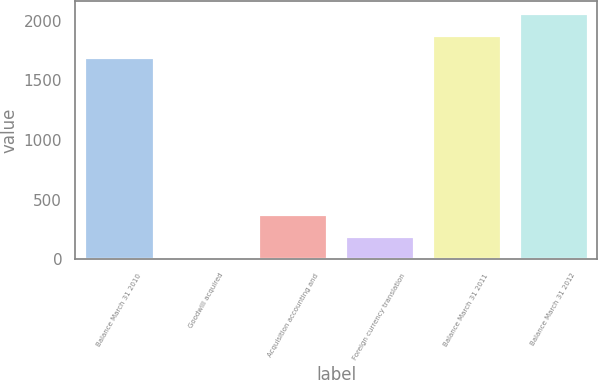Convert chart. <chart><loc_0><loc_0><loc_500><loc_500><bar_chart><fcel>Balance March 31 2010<fcel>Goodwill acquired<fcel>Acquisition accounting and<fcel>Foreign currency translation<fcel>Balance March 31 2011<fcel>Balance March 31 2012<nl><fcel>1697<fcel>8<fcel>374.8<fcel>191.4<fcel>1880.4<fcel>2063.8<nl></chart> 